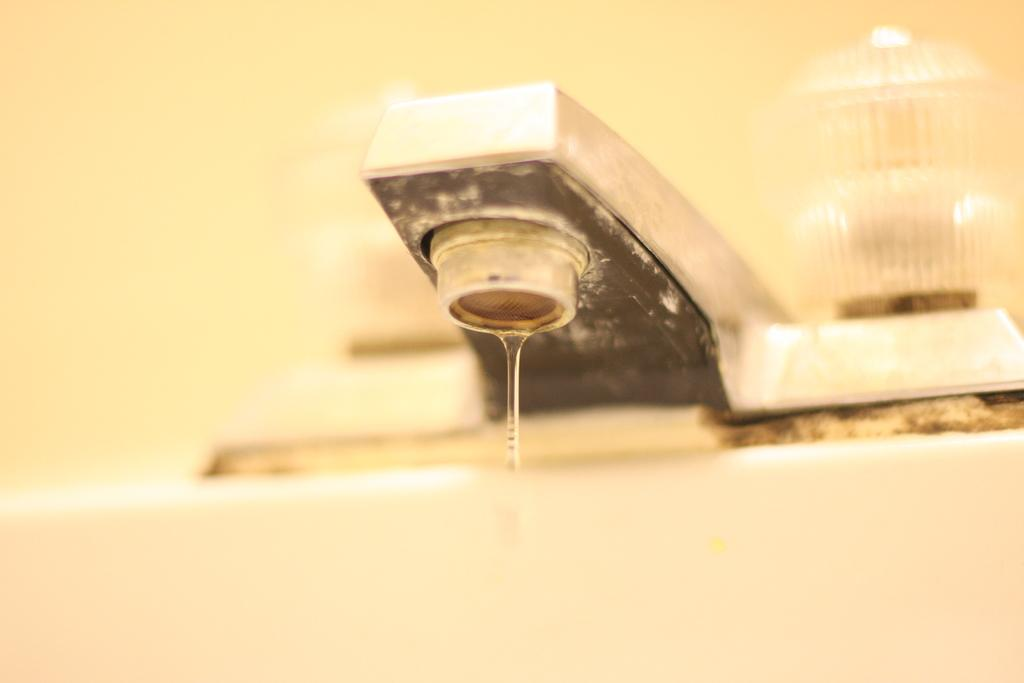What object in the image is releasing water? There is a tap in the image, and water is coming out of it. Can you describe the background of the image? The background of the image is blurred. What type of icicle can be seen hanging from the tap in the image? There is no icicle present in the image; it is a tap with water coming out of it. What is being served for dinner in the image? There is no reference to dinner or any food in the image. 